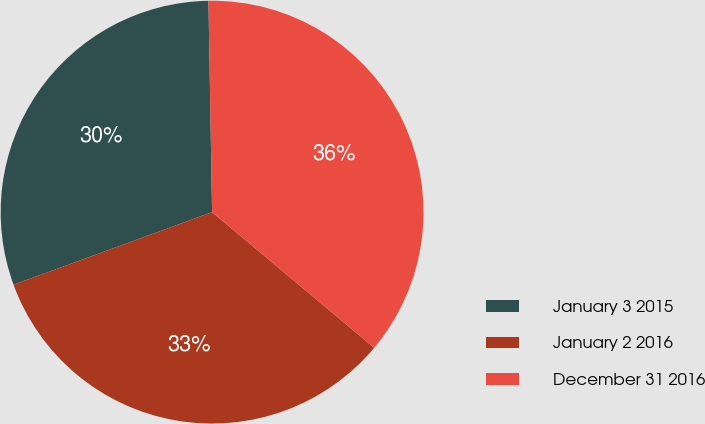<chart> <loc_0><loc_0><loc_500><loc_500><pie_chart><fcel>January 3 2015<fcel>January 2 2016<fcel>December 31 2016<nl><fcel>30.3%<fcel>33.33%<fcel>36.36%<nl></chart> 